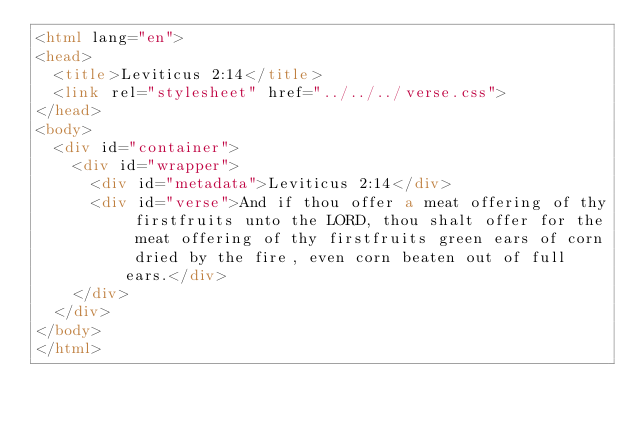Convert code to text. <code><loc_0><loc_0><loc_500><loc_500><_HTML_><html lang="en">
<head>
  <title>Leviticus 2:14</title>
  <link rel="stylesheet" href="../../../verse.css">
</head>
<body>
  <div id="container">
    <div id="wrapper">
      <div id="metadata">Leviticus 2:14</div>
      <div id="verse">And if thou offer a meat offering of thy firstfruits unto the LORD, thou shalt offer for the meat offering of thy firstfruits green ears of corn dried by the fire, even corn beaten out of full ears.</div>
    </div>
  </div>
</body>
</html></code> 